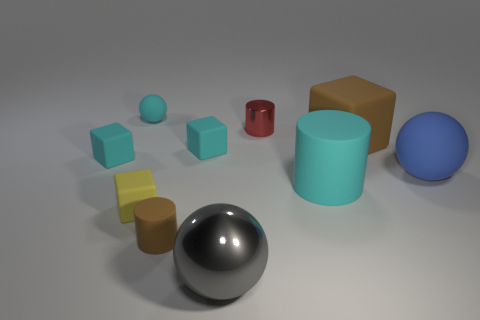Can you describe the object in the front center of the image and its appearance? Certainly! The object at the front and center appears to be a highly polished sphere with a reflective surface that suggests it's made of metal, likely chrome or steel, given its silvery color and shiny appearance. It is the most reflective object in this set. 